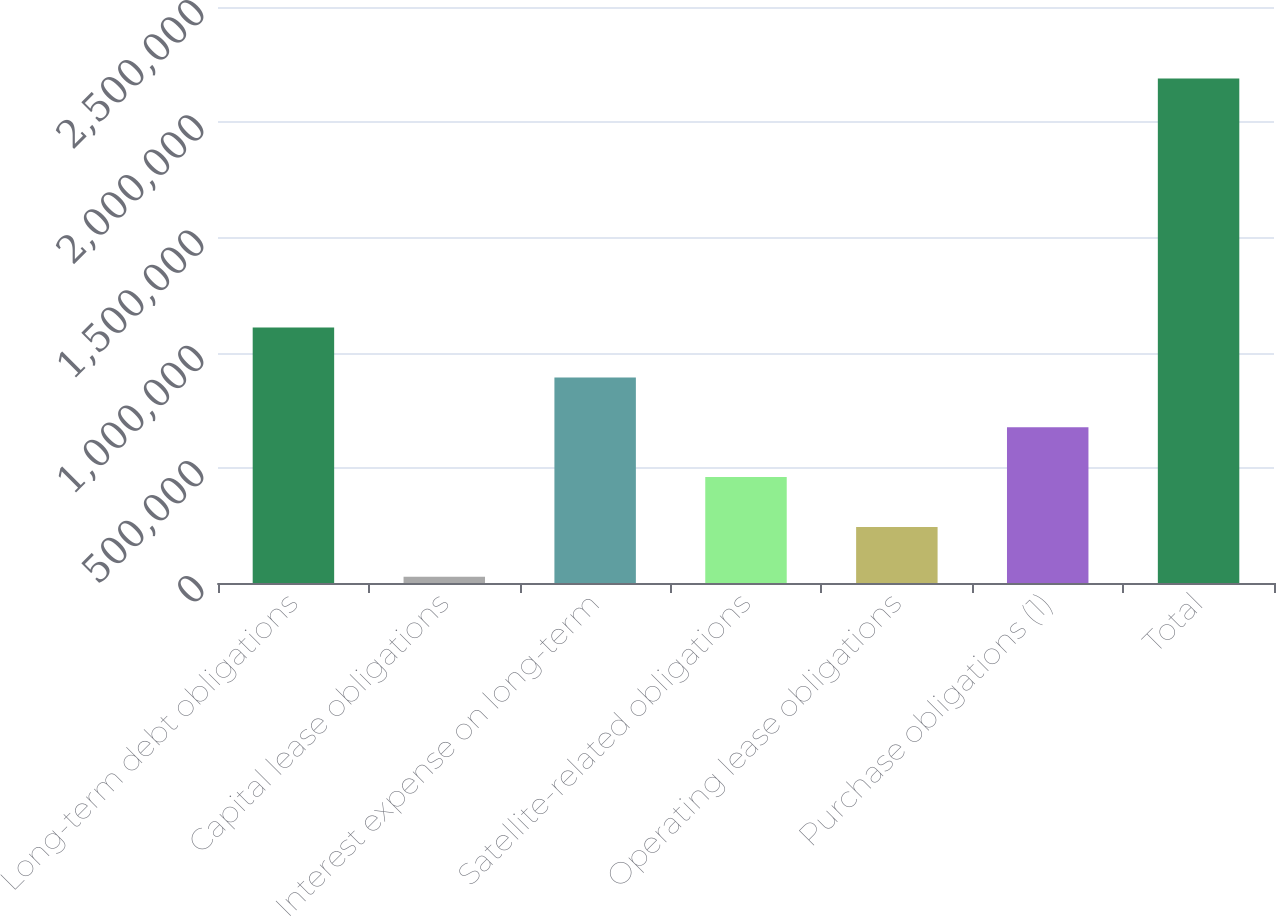Convert chart to OTSL. <chart><loc_0><loc_0><loc_500><loc_500><bar_chart><fcel>Long-term debt obligations<fcel>Capital lease obligations<fcel>Interest expense on long-term<fcel>Satellite-related obligations<fcel>Operating lease obligations<fcel>Purchase obligations (1)<fcel>Total<nl><fcel>1.10859e+06<fcel>27339<fcel>892338<fcel>459838<fcel>243589<fcel>676088<fcel>2.18984e+06<nl></chart> 